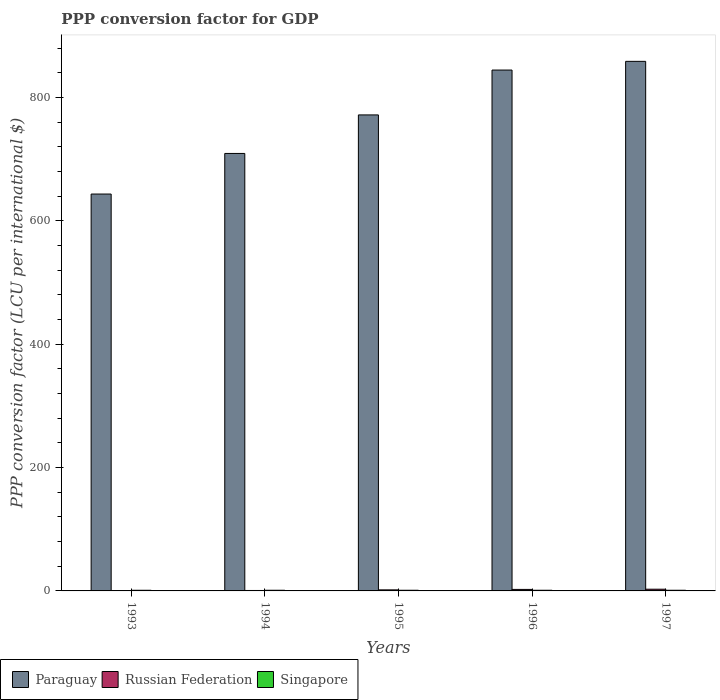How many different coloured bars are there?
Provide a short and direct response. 3. Are the number of bars per tick equal to the number of legend labels?
Offer a terse response. Yes. How many bars are there on the 3rd tick from the left?
Offer a very short reply. 3. How many bars are there on the 4th tick from the right?
Give a very brief answer. 3. What is the label of the 3rd group of bars from the left?
Ensure brevity in your answer.  1995. What is the PPP conversion factor for GDP in Paraguay in 1996?
Offer a terse response. 844.73. Across all years, what is the maximum PPP conversion factor for GDP in Russian Federation?
Your answer should be compact. 2.78. Across all years, what is the minimum PPP conversion factor for GDP in Russian Federation?
Provide a succinct answer. 0.18. In which year was the PPP conversion factor for GDP in Paraguay maximum?
Your answer should be very brief. 1997. In which year was the PPP conversion factor for GDP in Singapore minimum?
Your response must be concise. 1993. What is the total PPP conversion factor for GDP in Singapore in the graph?
Keep it short and to the point. 5.34. What is the difference between the PPP conversion factor for GDP in Paraguay in 1993 and that in 1994?
Offer a very short reply. -65.83. What is the difference between the PPP conversion factor for GDP in Paraguay in 1997 and the PPP conversion factor for GDP in Singapore in 1996?
Give a very brief answer. 857.77. What is the average PPP conversion factor for GDP in Russian Federation per year?
Provide a succinct answer. 1.57. In the year 1993, what is the difference between the PPP conversion factor for GDP in Russian Federation and PPP conversion factor for GDP in Paraguay?
Your response must be concise. -643.48. In how many years, is the PPP conversion factor for GDP in Paraguay greater than 320 LCU?
Offer a terse response. 5. What is the ratio of the PPP conversion factor for GDP in Paraguay in 1994 to that in 1997?
Provide a succinct answer. 0.83. Is the PPP conversion factor for GDP in Singapore in 1995 less than that in 1996?
Your answer should be very brief. No. What is the difference between the highest and the second highest PPP conversion factor for GDP in Singapore?
Offer a very short reply. 0. What is the difference between the highest and the lowest PPP conversion factor for GDP in Russian Federation?
Offer a terse response. 2.6. In how many years, is the PPP conversion factor for GDP in Paraguay greater than the average PPP conversion factor for GDP in Paraguay taken over all years?
Your answer should be very brief. 3. What does the 2nd bar from the left in 1996 represents?
Offer a very short reply. Russian Federation. What does the 2nd bar from the right in 1994 represents?
Your response must be concise. Russian Federation. Is it the case that in every year, the sum of the PPP conversion factor for GDP in Singapore and PPP conversion factor for GDP in Russian Federation is greater than the PPP conversion factor for GDP in Paraguay?
Offer a terse response. No. How many bars are there?
Provide a short and direct response. 15. Are all the bars in the graph horizontal?
Your response must be concise. No. What is the difference between two consecutive major ticks on the Y-axis?
Make the answer very short. 200. Does the graph contain any zero values?
Provide a short and direct response. No. Where does the legend appear in the graph?
Make the answer very short. Bottom left. How many legend labels are there?
Offer a very short reply. 3. What is the title of the graph?
Your answer should be very brief. PPP conversion factor for GDP. What is the label or title of the X-axis?
Your answer should be very brief. Years. What is the label or title of the Y-axis?
Your answer should be very brief. PPP conversion factor (LCU per international $). What is the PPP conversion factor (LCU per international $) in Paraguay in 1993?
Keep it short and to the point. 643.66. What is the PPP conversion factor (LCU per international $) in Russian Federation in 1993?
Provide a short and direct response. 0.18. What is the PPP conversion factor (LCU per international $) in Singapore in 1993?
Offer a very short reply. 1.05. What is the PPP conversion factor (LCU per international $) of Paraguay in 1994?
Provide a short and direct response. 709.49. What is the PPP conversion factor (LCU per international $) of Russian Federation in 1994?
Offer a very short reply. 0.72. What is the PPP conversion factor (LCU per international $) of Singapore in 1994?
Your answer should be compact. 1.07. What is the PPP conversion factor (LCU per international $) in Paraguay in 1995?
Make the answer very short. 771.98. What is the PPP conversion factor (LCU per international $) of Russian Federation in 1995?
Offer a very short reply. 1.72. What is the PPP conversion factor (LCU per international $) in Singapore in 1995?
Your response must be concise. 1.08. What is the PPP conversion factor (LCU per international $) in Paraguay in 1996?
Provide a short and direct response. 844.73. What is the PPP conversion factor (LCU per international $) of Russian Federation in 1996?
Give a very brief answer. 2.46. What is the PPP conversion factor (LCU per international $) of Singapore in 1996?
Your response must be concise. 1.08. What is the PPP conversion factor (LCU per international $) of Paraguay in 1997?
Your answer should be very brief. 858.84. What is the PPP conversion factor (LCU per international $) of Russian Federation in 1997?
Provide a short and direct response. 2.78. What is the PPP conversion factor (LCU per international $) of Singapore in 1997?
Your answer should be compact. 1.07. Across all years, what is the maximum PPP conversion factor (LCU per international $) in Paraguay?
Offer a very short reply. 858.84. Across all years, what is the maximum PPP conversion factor (LCU per international $) in Russian Federation?
Give a very brief answer. 2.78. Across all years, what is the maximum PPP conversion factor (LCU per international $) in Singapore?
Offer a terse response. 1.08. Across all years, what is the minimum PPP conversion factor (LCU per international $) in Paraguay?
Make the answer very short. 643.66. Across all years, what is the minimum PPP conversion factor (LCU per international $) in Russian Federation?
Provide a short and direct response. 0.18. Across all years, what is the minimum PPP conversion factor (LCU per international $) in Singapore?
Provide a short and direct response. 1.05. What is the total PPP conversion factor (LCU per international $) of Paraguay in the graph?
Keep it short and to the point. 3828.7. What is the total PPP conversion factor (LCU per international $) in Russian Federation in the graph?
Offer a terse response. 7.85. What is the total PPP conversion factor (LCU per international $) in Singapore in the graph?
Provide a succinct answer. 5.34. What is the difference between the PPP conversion factor (LCU per international $) of Paraguay in 1993 and that in 1994?
Offer a terse response. -65.83. What is the difference between the PPP conversion factor (LCU per international $) of Russian Federation in 1993 and that in 1994?
Keep it short and to the point. -0.54. What is the difference between the PPP conversion factor (LCU per international $) in Singapore in 1993 and that in 1994?
Your answer should be very brief. -0.02. What is the difference between the PPP conversion factor (LCU per international $) of Paraguay in 1993 and that in 1995?
Your answer should be very brief. -128.32. What is the difference between the PPP conversion factor (LCU per international $) of Russian Federation in 1993 and that in 1995?
Offer a very short reply. -1.54. What is the difference between the PPP conversion factor (LCU per international $) in Singapore in 1993 and that in 1995?
Make the answer very short. -0.03. What is the difference between the PPP conversion factor (LCU per international $) of Paraguay in 1993 and that in 1996?
Your answer should be very brief. -201.07. What is the difference between the PPP conversion factor (LCU per international $) in Russian Federation in 1993 and that in 1996?
Keep it short and to the point. -2.28. What is the difference between the PPP conversion factor (LCU per international $) of Singapore in 1993 and that in 1996?
Your answer should be compact. -0.02. What is the difference between the PPP conversion factor (LCU per international $) of Paraguay in 1993 and that in 1997?
Make the answer very short. -215.18. What is the difference between the PPP conversion factor (LCU per international $) of Russian Federation in 1993 and that in 1997?
Make the answer very short. -2.6. What is the difference between the PPP conversion factor (LCU per international $) in Singapore in 1993 and that in 1997?
Your answer should be very brief. -0.02. What is the difference between the PPP conversion factor (LCU per international $) in Paraguay in 1994 and that in 1995?
Offer a terse response. -62.49. What is the difference between the PPP conversion factor (LCU per international $) in Russian Federation in 1994 and that in 1995?
Give a very brief answer. -1. What is the difference between the PPP conversion factor (LCU per international $) of Singapore in 1994 and that in 1995?
Your answer should be compact. -0.01. What is the difference between the PPP conversion factor (LCU per international $) in Paraguay in 1994 and that in 1996?
Keep it short and to the point. -135.24. What is the difference between the PPP conversion factor (LCU per international $) in Russian Federation in 1994 and that in 1996?
Provide a succinct answer. -1.74. What is the difference between the PPP conversion factor (LCU per international $) of Singapore in 1994 and that in 1996?
Your response must be concise. -0.01. What is the difference between the PPP conversion factor (LCU per international $) of Paraguay in 1994 and that in 1997?
Ensure brevity in your answer.  -149.35. What is the difference between the PPP conversion factor (LCU per international $) in Russian Federation in 1994 and that in 1997?
Offer a terse response. -2.06. What is the difference between the PPP conversion factor (LCU per international $) of Singapore in 1994 and that in 1997?
Your answer should be compact. -0. What is the difference between the PPP conversion factor (LCU per international $) of Paraguay in 1995 and that in 1996?
Keep it short and to the point. -72.75. What is the difference between the PPP conversion factor (LCU per international $) of Russian Federation in 1995 and that in 1996?
Provide a succinct answer. -0.74. What is the difference between the PPP conversion factor (LCU per international $) of Singapore in 1995 and that in 1996?
Your answer should be very brief. 0. What is the difference between the PPP conversion factor (LCU per international $) in Paraguay in 1995 and that in 1997?
Provide a succinct answer. -86.86. What is the difference between the PPP conversion factor (LCU per international $) in Russian Federation in 1995 and that in 1997?
Keep it short and to the point. -1.06. What is the difference between the PPP conversion factor (LCU per international $) in Singapore in 1995 and that in 1997?
Offer a terse response. 0.01. What is the difference between the PPP conversion factor (LCU per international $) of Paraguay in 1996 and that in 1997?
Your response must be concise. -14.11. What is the difference between the PPP conversion factor (LCU per international $) of Russian Federation in 1996 and that in 1997?
Offer a terse response. -0.32. What is the difference between the PPP conversion factor (LCU per international $) in Singapore in 1996 and that in 1997?
Provide a succinct answer. 0.01. What is the difference between the PPP conversion factor (LCU per international $) in Paraguay in 1993 and the PPP conversion factor (LCU per international $) in Russian Federation in 1994?
Provide a succinct answer. 642.94. What is the difference between the PPP conversion factor (LCU per international $) of Paraguay in 1993 and the PPP conversion factor (LCU per international $) of Singapore in 1994?
Make the answer very short. 642.59. What is the difference between the PPP conversion factor (LCU per international $) in Russian Federation in 1993 and the PPP conversion factor (LCU per international $) in Singapore in 1994?
Offer a very short reply. -0.89. What is the difference between the PPP conversion factor (LCU per international $) in Paraguay in 1993 and the PPP conversion factor (LCU per international $) in Russian Federation in 1995?
Ensure brevity in your answer.  641.95. What is the difference between the PPP conversion factor (LCU per international $) of Paraguay in 1993 and the PPP conversion factor (LCU per international $) of Singapore in 1995?
Keep it short and to the point. 642.58. What is the difference between the PPP conversion factor (LCU per international $) in Russian Federation in 1993 and the PPP conversion factor (LCU per international $) in Singapore in 1995?
Offer a terse response. -0.9. What is the difference between the PPP conversion factor (LCU per international $) of Paraguay in 1993 and the PPP conversion factor (LCU per international $) of Russian Federation in 1996?
Your answer should be very brief. 641.2. What is the difference between the PPP conversion factor (LCU per international $) in Paraguay in 1993 and the PPP conversion factor (LCU per international $) in Singapore in 1996?
Provide a succinct answer. 642.58. What is the difference between the PPP conversion factor (LCU per international $) of Russian Federation in 1993 and the PPP conversion factor (LCU per international $) of Singapore in 1996?
Ensure brevity in your answer.  -0.9. What is the difference between the PPP conversion factor (LCU per international $) in Paraguay in 1993 and the PPP conversion factor (LCU per international $) in Russian Federation in 1997?
Give a very brief answer. 640.88. What is the difference between the PPP conversion factor (LCU per international $) of Paraguay in 1993 and the PPP conversion factor (LCU per international $) of Singapore in 1997?
Provide a succinct answer. 642.59. What is the difference between the PPP conversion factor (LCU per international $) of Russian Federation in 1993 and the PPP conversion factor (LCU per international $) of Singapore in 1997?
Offer a terse response. -0.89. What is the difference between the PPP conversion factor (LCU per international $) in Paraguay in 1994 and the PPP conversion factor (LCU per international $) in Russian Federation in 1995?
Your answer should be compact. 707.78. What is the difference between the PPP conversion factor (LCU per international $) of Paraguay in 1994 and the PPP conversion factor (LCU per international $) of Singapore in 1995?
Your response must be concise. 708.41. What is the difference between the PPP conversion factor (LCU per international $) in Russian Federation in 1994 and the PPP conversion factor (LCU per international $) in Singapore in 1995?
Your answer should be very brief. -0.36. What is the difference between the PPP conversion factor (LCU per international $) in Paraguay in 1994 and the PPP conversion factor (LCU per international $) in Russian Federation in 1996?
Provide a short and direct response. 707.04. What is the difference between the PPP conversion factor (LCU per international $) in Paraguay in 1994 and the PPP conversion factor (LCU per international $) in Singapore in 1996?
Keep it short and to the point. 708.42. What is the difference between the PPP conversion factor (LCU per international $) of Russian Federation in 1994 and the PPP conversion factor (LCU per international $) of Singapore in 1996?
Offer a terse response. -0.36. What is the difference between the PPP conversion factor (LCU per international $) of Paraguay in 1994 and the PPP conversion factor (LCU per international $) of Russian Federation in 1997?
Make the answer very short. 706.71. What is the difference between the PPP conversion factor (LCU per international $) in Paraguay in 1994 and the PPP conversion factor (LCU per international $) in Singapore in 1997?
Your response must be concise. 708.42. What is the difference between the PPP conversion factor (LCU per international $) in Russian Federation in 1994 and the PPP conversion factor (LCU per international $) in Singapore in 1997?
Ensure brevity in your answer.  -0.35. What is the difference between the PPP conversion factor (LCU per international $) of Paraguay in 1995 and the PPP conversion factor (LCU per international $) of Russian Federation in 1996?
Provide a short and direct response. 769.52. What is the difference between the PPP conversion factor (LCU per international $) of Paraguay in 1995 and the PPP conversion factor (LCU per international $) of Singapore in 1996?
Keep it short and to the point. 770.9. What is the difference between the PPP conversion factor (LCU per international $) in Russian Federation in 1995 and the PPP conversion factor (LCU per international $) in Singapore in 1996?
Ensure brevity in your answer.  0.64. What is the difference between the PPP conversion factor (LCU per international $) of Paraguay in 1995 and the PPP conversion factor (LCU per international $) of Russian Federation in 1997?
Provide a succinct answer. 769.2. What is the difference between the PPP conversion factor (LCU per international $) in Paraguay in 1995 and the PPP conversion factor (LCU per international $) in Singapore in 1997?
Your answer should be compact. 770.91. What is the difference between the PPP conversion factor (LCU per international $) in Russian Federation in 1995 and the PPP conversion factor (LCU per international $) in Singapore in 1997?
Your response must be concise. 0.65. What is the difference between the PPP conversion factor (LCU per international $) in Paraguay in 1996 and the PPP conversion factor (LCU per international $) in Russian Federation in 1997?
Keep it short and to the point. 841.95. What is the difference between the PPP conversion factor (LCU per international $) of Paraguay in 1996 and the PPP conversion factor (LCU per international $) of Singapore in 1997?
Keep it short and to the point. 843.66. What is the difference between the PPP conversion factor (LCU per international $) in Russian Federation in 1996 and the PPP conversion factor (LCU per international $) in Singapore in 1997?
Your answer should be very brief. 1.39. What is the average PPP conversion factor (LCU per international $) in Paraguay per year?
Provide a short and direct response. 765.74. What is the average PPP conversion factor (LCU per international $) of Russian Federation per year?
Offer a very short reply. 1.57. What is the average PPP conversion factor (LCU per international $) in Singapore per year?
Make the answer very short. 1.07. In the year 1993, what is the difference between the PPP conversion factor (LCU per international $) of Paraguay and PPP conversion factor (LCU per international $) of Russian Federation?
Give a very brief answer. 643.48. In the year 1993, what is the difference between the PPP conversion factor (LCU per international $) in Paraguay and PPP conversion factor (LCU per international $) in Singapore?
Your response must be concise. 642.61. In the year 1993, what is the difference between the PPP conversion factor (LCU per international $) in Russian Federation and PPP conversion factor (LCU per international $) in Singapore?
Keep it short and to the point. -0.87. In the year 1994, what is the difference between the PPP conversion factor (LCU per international $) in Paraguay and PPP conversion factor (LCU per international $) in Russian Federation?
Your response must be concise. 708.77. In the year 1994, what is the difference between the PPP conversion factor (LCU per international $) in Paraguay and PPP conversion factor (LCU per international $) in Singapore?
Offer a very short reply. 708.42. In the year 1994, what is the difference between the PPP conversion factor (LCU per international $) of Russian Federation and PPP conversion factor (LCU per international $) of Singapore?
Offer a terse response. -0.35. In the year 1995, what is the difference between the PPP conversion factor (LCU per international $) of Paraguay and PPP conversion factor (LCU per international $) of Russian Federation?
Provide a succinct answer. 770.26. In the year 1995, what is the difference between the PPP conversion factor (LCU per international $) of Paraguay and PPP conversion factor (LCU per international $) of Singapore?
Your answer should be compact. 770.9. In the year 1995, what is the difference between the PPP conversion factor (LCU per international $) in Russian Federation and PPP conversion factor (LCU per international $) in Singapore?
Make the answer very short. 0.64. In the year 1996, what is the difference between the PPP conversion factor (LCU per international $) in Paraguay and PPP conversion factor (LCU per international $) in Russian Federation?
Keep it short and to the point. 842.27. In the year 1996, what is the difference between the PPP conversion factor (LCU per international $) in Paraguay and PPP conversion factor (LCU per international $) in Singapore?
Your response must be concise. 843.65. In the year 1996, what is the difference between the PPP conversion factor (LCU per international $) of Russian Federation and PPP conversion factor (LCU per international $) of Singapore?
Offer a terse response. 1.38. In the year 1997, what is the difference between the PPP conversion factor (LCU per international $) in Paraguay and PPP conversion factor (LCU per international $) in Russian Federation?
Ensure brevity in your answer.  856.06. In the year 1997, what is the difference between the PPP conversion factor (LCU per international $) in Paraguay and PPP conversion factor (LCU per international $) in Singapore?
Offer a terse response. 857.77. In the year 1997, what is the difference between the PPP conversion factor (LCU per international $) of Russian Federation and PPP conversion factor (LCU per international $) of Singapore?
Provide a succinct answer. 1.71. What is the ratio of the PPP conversion factor (LCU per international $) in Paraguay in 1993 to that in 1994?
Offer a terse response. 0.91. What is the ratio of the PPP conversion factor (LCU per international $) in Russian Federation in 1993 to that in 1994?
Provide a short and direct response. 0.25. What is the ratio of the PPP conversion factor (LCU per international $) in Singapore in 1993 to that in 1994?
Offer a very short reply. 0.99. What is the ratio of the PPP conversion factor (LCU per international $) of Paraguay in 1993 to that in 1995?
Provide a succinct answer. 0.83. What is the ratio of the PPP conversion factor (LCU per international $) in Russian Federation in 1993 to that in 1995?
Offer a very short reply. 0.1. What is the ratio of the PPP conversion factor (LCU per international $) of Singapore in 1993 to that in 1995?
Offer a very short reply. 0.97. What is the ratio of the PPP conversion factor (LCU per international $) of Paraguay in 1993 to that in 1996?
Provide a succinct answer. 0.76. What is the ratio of the PPP conversion factor (LCU per international $) of Russian Federation in 1993 to that in 1996?
Provide a succinct answer. 0.07. What is the ratio of the PPP conversion factor (LCU per international $) of Singapore in 1993 to that in 1996?
Your answer should be very brief. 0.98. What is the ratio of the PPP conversion factor (LCU per international $) in Paraguay in 1993 to that in 1997?
Your answer should be very brief. 0.75. What is the ratio of the PPP conversion factor (LCU per international $) of Russian Federation in 1993 to that in 1997?
Your answer should be compact. 0.06. What is the ratio of the PPP conversion factor (LCU per international $) in Singapore in 1993 to that in 1997?
Your response must be concise. 0.98. What is the ratio of the PPP conversion factor (LCU per international $) in Paraguay in 1994 to that in 1995?
Your response must be concise. 0.92. What is the ratio of the PPP conversion factor (LCU per international $) of Russian Federation in 1994 to that in 1995?
Ensure brevity in your answer.  0.42. What is the ratio of the PPP conversion factor (LCU per international $) in Singapore in 1994 to that in 1995?
Ensure brevity in your answer.  0.99. What is the ratio of the PPP conversion factor (LCU per international $) in Paraguay in 1994 to that in 1996?
Ensure brevity in your answer.  0.84. What is the ratio of the PPP conversion factor (LCU per international $) of Russian Federation in 1994 to that in 1996?
Offer a terse response. 0.29. What is the ratio of the PPP conversion factor (LCU per international $) of Singapore in 1994 to that in 1996?
Make the answer very short. 0.99. What is the ratio of the PPP conversion factor (LCU per international $) of Paraguay in 1994 to that in 1997?
Your answer should be compact. 0.83. What is the ratio of the PPP conversion factor (LCU per international $) in Russian Federation in 1994 to that in 1997?
Provide a succinct answer. 0.26. What is the ratio of the PPP conversion factor (LCU per international $) in Singapore in 1994 to that in 1997?
Offer a very short reply. 1. What is the ratio of the PPP conversion factor (LCU per international $) of Paraguay in 1995 to that in 1996?
Keep it short and to the point. 0.91. What is the ratio of the PPP conversion factor (LCU per international $) in Russian Federation in 1995 to that in 1996?
Keep it short and to the point. 0.7. What is the ratio of the PPP conversion factor (LCU per international $) of Singapore in 1995 to that in 1996?
Keep it short and to the point. 1. What is the ratio of the PPP conversion factor (LCU per international $) in Paraguay in 1995 to that in 1997?
Ensure brevity in your answer.  0.9. What is the ratio of the PPP conversion factor (LCU per international $) in Russian Federation in 1995 to that in 1997?
Offer a terse response. 0.62. What is the ratio of the PPP conversion factor (LCU per international $) in Singapore in 1995 to that in 1997?
Give a very brief answer. 1.01. What is the ratio of the PPP conversion factor (LCU per international $) in Paraguay in 1996 to that in 1997?
Your response must be concise. 0.98. What is the ratio of the PPP conversion factor (LCU per international $) in Russian Federation in 1996 to that in 1997?
Offer a very short reply. 0.88. What is the difference between the highest and the second highest PPP conversion factor (LCU per international $) in Paraguay?
Make the answer very short. 14.11. What is the difference between the highest and the second highest PPP conversion factor (LCU per international $) of Russian Federation?
Offer a terse response. 0.32. What is the difference between the highest and the second highest PPP conversion factor (LCU per international $) in Singapore?
Provide a succinct answer. 0. What is the difference between the highest and the lowest PPP conversion factor (LCU per international $) of Paraguay?
Ensure brevity in your answer.  215.18. What is the difference between the highest and the lowest PPP conversion factor (LCU per international $) of Russian Federation?
Give a very brief answer. 2.6. What is the difference between the highest and the lowest PPP conversion factor (LCU per international $) in Singapore?
Give a very brief answer. 0.03. 